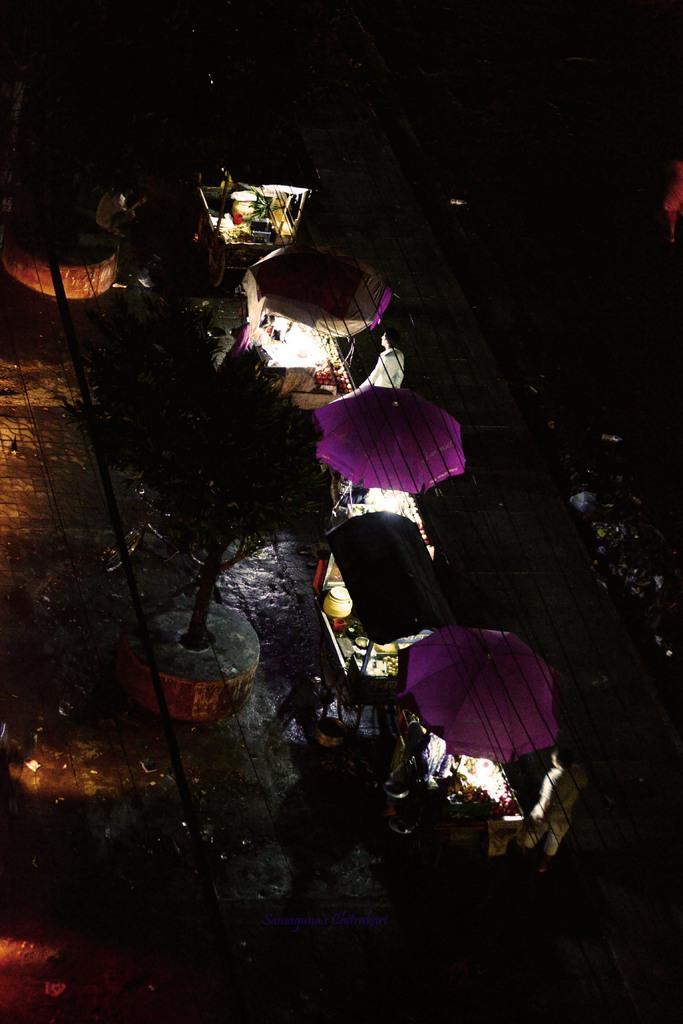Could you give a brief overview of what you see in this image? In the picture I can see stalls, lights, a tree and some other objects on the ground. This image is little bit dark. 